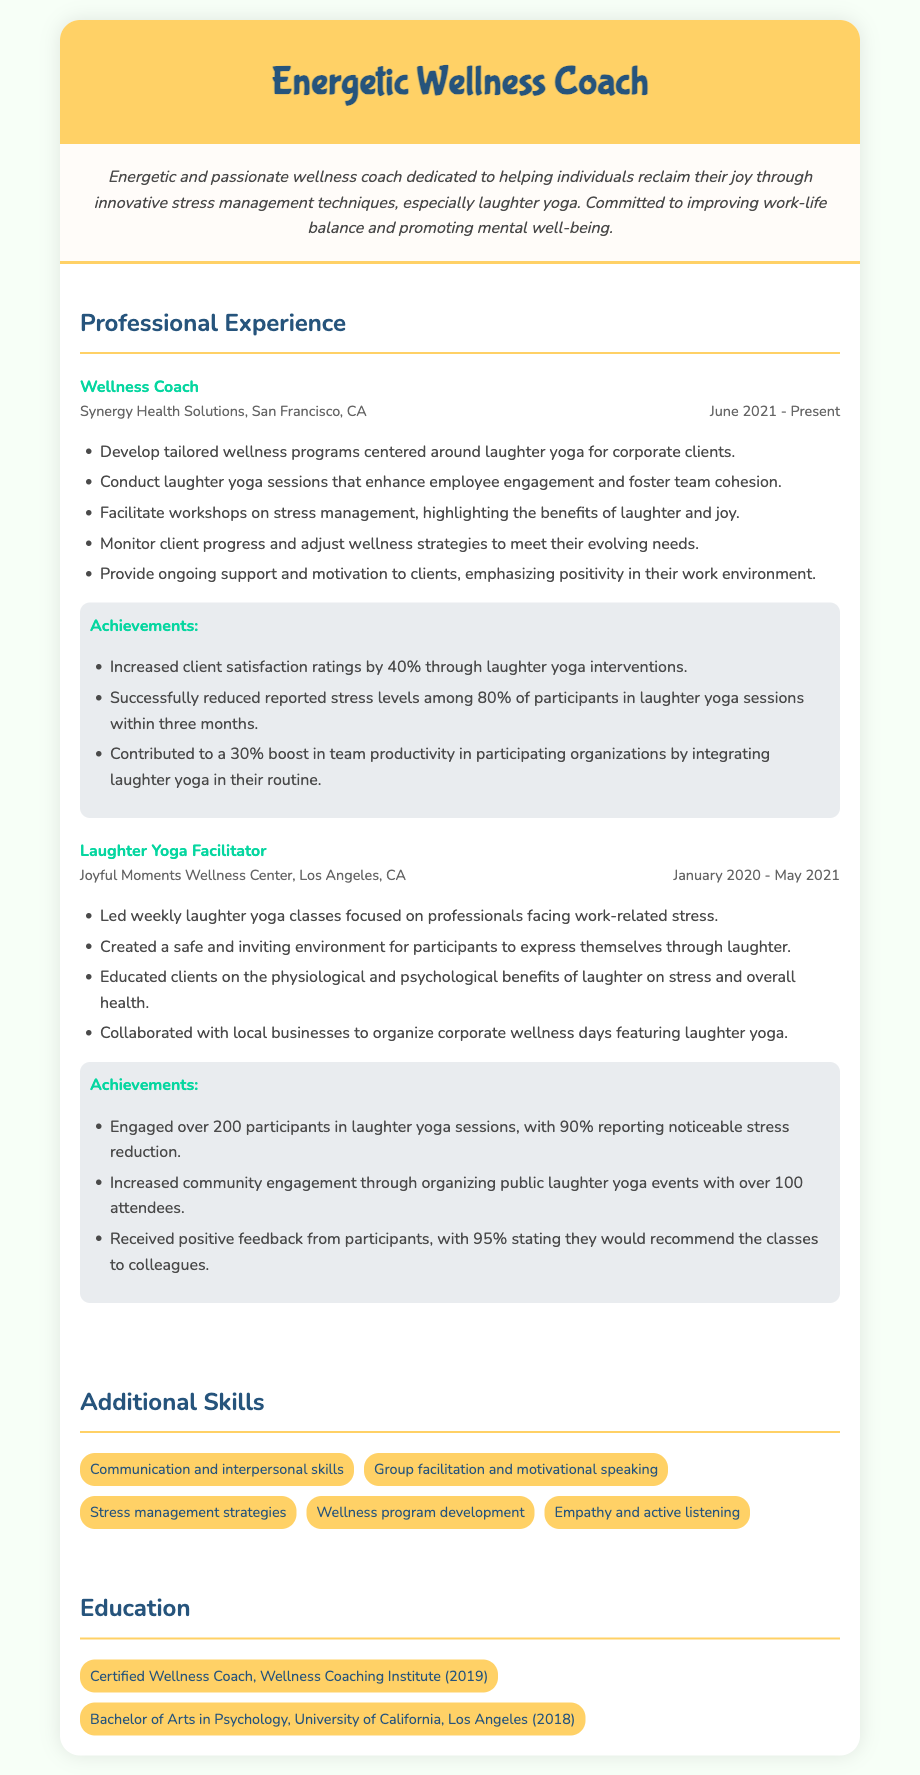What is the job title of the current role? The current role's title is listed under the 'Professional Experience' section as "Wellness Coach."
Answer: Wellness Coach Where is the first job located? The location of the first job, "Wellness Coach," is specified as San Francisco, CA.
Answer: San Francisco, CA What percentage of participants reported stress reduction after laughter yoga sessions? The document indicates that 90% of participants reported noticeable stress reduction from laughter yoga sessions conducted at Joyful Moments Wellness Center.
Answer: 90% How many participants engaged in laughter yoga sessions at Joyful Moments Wellness Center? The document states the total number of participants who engaged in sessions at Joyful Moments Wellness Center as over 200.
Answer: Over 200 What is the duration of the role at Synergy Health Solutions? The duration of the role at Synergy Health Solutions is specified as "June 2021 - Present," indicating a continuous employment period.
Answer: June 2021 - Present What was a key achievement related to stress levels at Synergy Health Solutions? The document mentions that laughter yoga interventions reduced reported stress levels among 80% of participants within three months.
Answer: 80% Which skill emphasizes the ability to listen actively? The skill that specifically emphasizes the ability to listen actively is "Empathy and active listening."
Answer: Empathy and active listening What kind of programs did the wellness coach develop? The wellness coach developed tailored wellness programs centered around laughter yoga for corporate clients.
Answer: Tailored wellness programs centered around laughter yoga Who provided positive feedback on the classes? The positive feedback was received from the participants, specifically with 95% stating they would recommend the classes.
Answer: Participants 